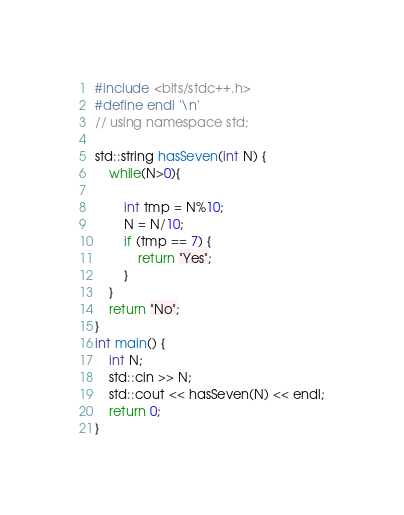Convert code to text. <code><loc_0><loc_0><loc_500><loc_500><_C++_>#include <bits/stdc++.h>
#define endl '\n'
// using namespace std;

std::string hasSeven(int N) {
    while(N>0){
         
        int tmp = N%10;
        N = N/10;
        if (tmp == 7) {
            return "Yes";
        }
    }
    return "No";
}
int main() {
    int N;
    std::cin >> N;
    std::cout << hasSeven(N) << endl;
    return 0;
}</code> 